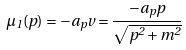Convert formula to latex. <formula><loc_0><loc_0><loc_500><loc_500>\mu _ { 1 } ( p ) = - a _ { p } v = \frac { - a _ { p } p } { \sqrt { p ^ { 2 } + m ^ { 2 } } }</formula> 